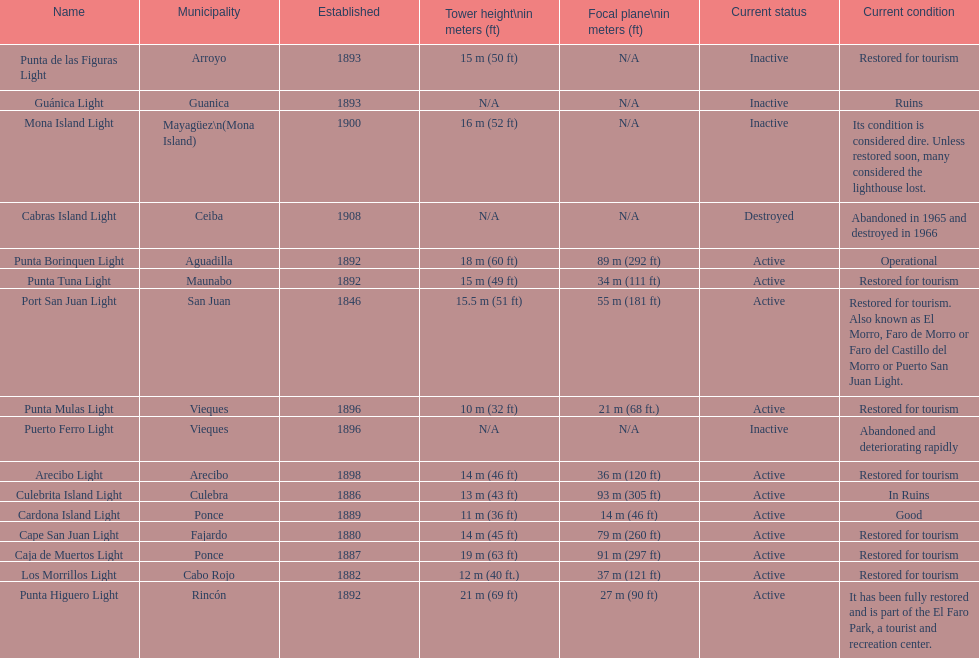What is the largest tower Punta Higuero Light. 